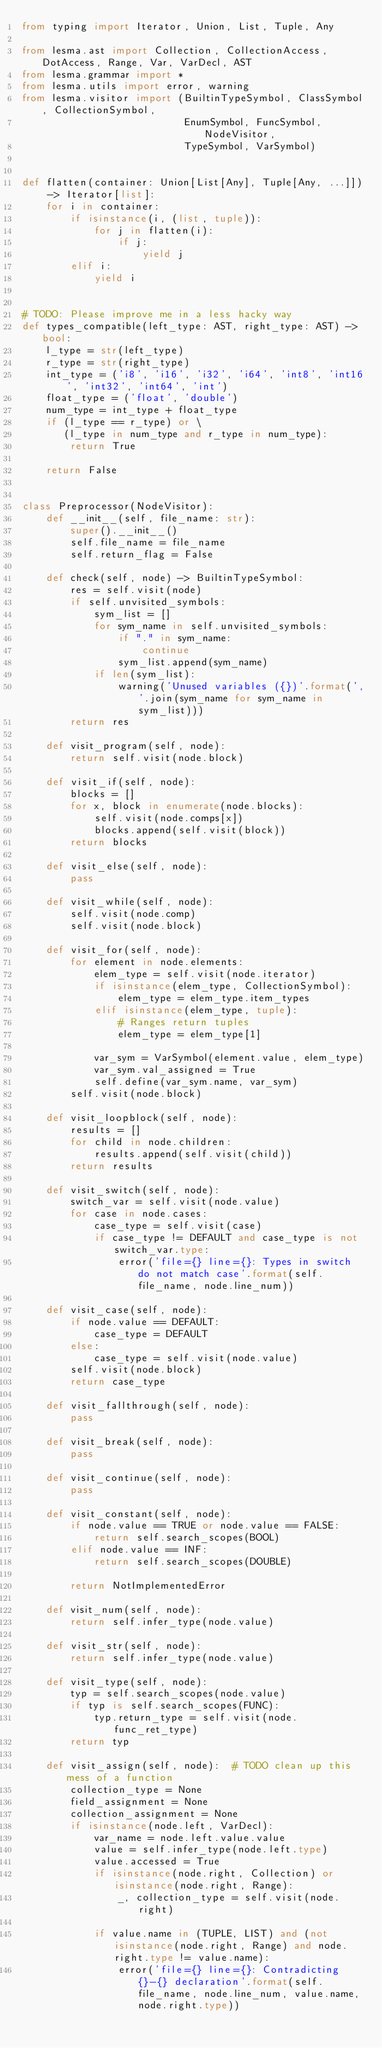Convert code to text. <code><loc_0><loc_0><loc_500><loc_500><_Python_>from typing import Iterator, Union, List, Tuple, Any

from lesma.ast import Collection, CollectionAccess, DotAccess, Range, Var, VarDecl, AST
from lesma.grammar import *
from lesma.utils import error, warning
from lesma.visitor import (BuiltinTypeSymbol, ClassSymbol, CollectionSymbol,
                           EnumSymbol, FuncSymbol, NodeVisitor,
                           TypeSymbol, VarSymbol)


def flatten(container: Union[List[Any], Tuple[Any, ...]]) -> Iterator[list]:
    for i in container:
        if isinstance(i, (list, tuple)):
            for j in flatten(i):
                if j:
                    yield j
        elif i:
            yield i


# TODO: Please improve me in a less hacky way
def types_compatible(left_type: AST, right_type: AST) -> bool:
    l_type = str(left_type)
    r_type = str(right_type)
    int_type = ('i8', 'i16', 'i32', 'i64', 'int8', 'int16', 'int32', 'int64', 'int')
    float_type = ('float', 'double')
    num_type = int_type + float_type
    if (l_type == r_type) or \
       (l_type in num_type and r_type in num_type):
        return True

    return False


class Preprocessor(NodeVisitor):
    def __init__(self, file_name: str):
        super().__init__()
        self.file_name = file_name
        self.return_flag = False

    def check(self, node) -> BuiltinTypeSymbol:
        res = self.visit(node)
        if self.unvisited_symbols:
            sym_list = []
            for sym_name in self.unvisited_symbols:
                if "." in sym_name:
                    continue
                sym_list.append(sym_name)
            if len(sym_list):
                warning('Unused variables ({})'.format(','.join(sym_name for sym_name in sym_list)))
        return res

    def visit_program(self, node):
        return self.visit(node.block)

    def visit_if(self, node):
        blocks = []
        for x, block in enumerate(node.blocks):
            self.visit(node.comps[x])
            blocks.append(self.visit(block))
        return blocks

    def visit_else(self, node):
        pass

    def visit_while(self, node):
        self.visit(node.comp)
        self.visit(node.block)

    def visit_for(self, node):
        for element in node.elements:
            elem_type = self.visit(node.iterator)
            if isinstance(elem_type, CollectionSymbol):
                elem_type = elem_type.item_types
            elif isinstance(elem_type, tuple):
                # Ranges return tuples
                elem_type = elem_type[1]

            var_sym = VarSymbol(element.value, elem_type)
            var_sym.val_assigned = True
            self.define(var_sym.name, var_sym)
        self.visit(node.block)

    def visit_loopblock(self, node):
        results = []
        for child in node.children:
            results.append(self.visit(child))
        return results

    def visit_switch(self, node):
        switch_var = self.visit(node.value)
        for case in node.cases:
            case_type = self.visit(case)
            if case_type != DEFAULT and case_type is not switch_var.type:
                error('file={} line={}: Types in switch do not match case'.format(self.file_name, node.line_num))

    def visit_case(self, node):
        if node.value == DEFAULT:
            case_type = DEFAULT
        else:
            case_type = self.visit(node.value)
        self.visit(node.block)
        return case_type

    def visit_fallthrough(self, node):
        pass

    def visit_break(self, node):
        pass

    def visit_continue(self, node):
        pass

    def visit_constant(self, node):
        if node.value == TRUE or node.value == FALSE:
            return self.search_scopes(BOOL)
        elif node.value == INF:
            return self.search_scopes(DOUBLE)

        return NotImplementedError

    def visit_num(self, node):
        return self.infer_type(node.value)

    def visit_str(self, node):
        return self.infer_type(node.value)

    def visit_type(self, node):
        typ = self.search_scopes(node.value)
        if typ is self.search_scopes(FUNC):
            typ.return_type = self.visit(node.func_ret_type)
        return typ

    def visit_assign(self, node):  # TODO clean up this mess of a function
        collection_type = None
        field_assignment = None
        collection_assignment = None
        if isinstance(node.left, VarDecl):
            var_name = node.left.value.value
            value = self.infer_type(node.left.type)
            value.accessed = True
            if isinstance(node.right, Collection) or isinstance(node.right, Range):
                _, collection_type = self.visit(node.right)

            if value.name in (TUPLE, LIST) and (not isinstance(node.right, Range) and node.right.type != value.name):
                error('file={} line={}: Contradicting {}-{} declaration'.format(self.file_name, node.line_num, value.name, node.right.type))</code> 